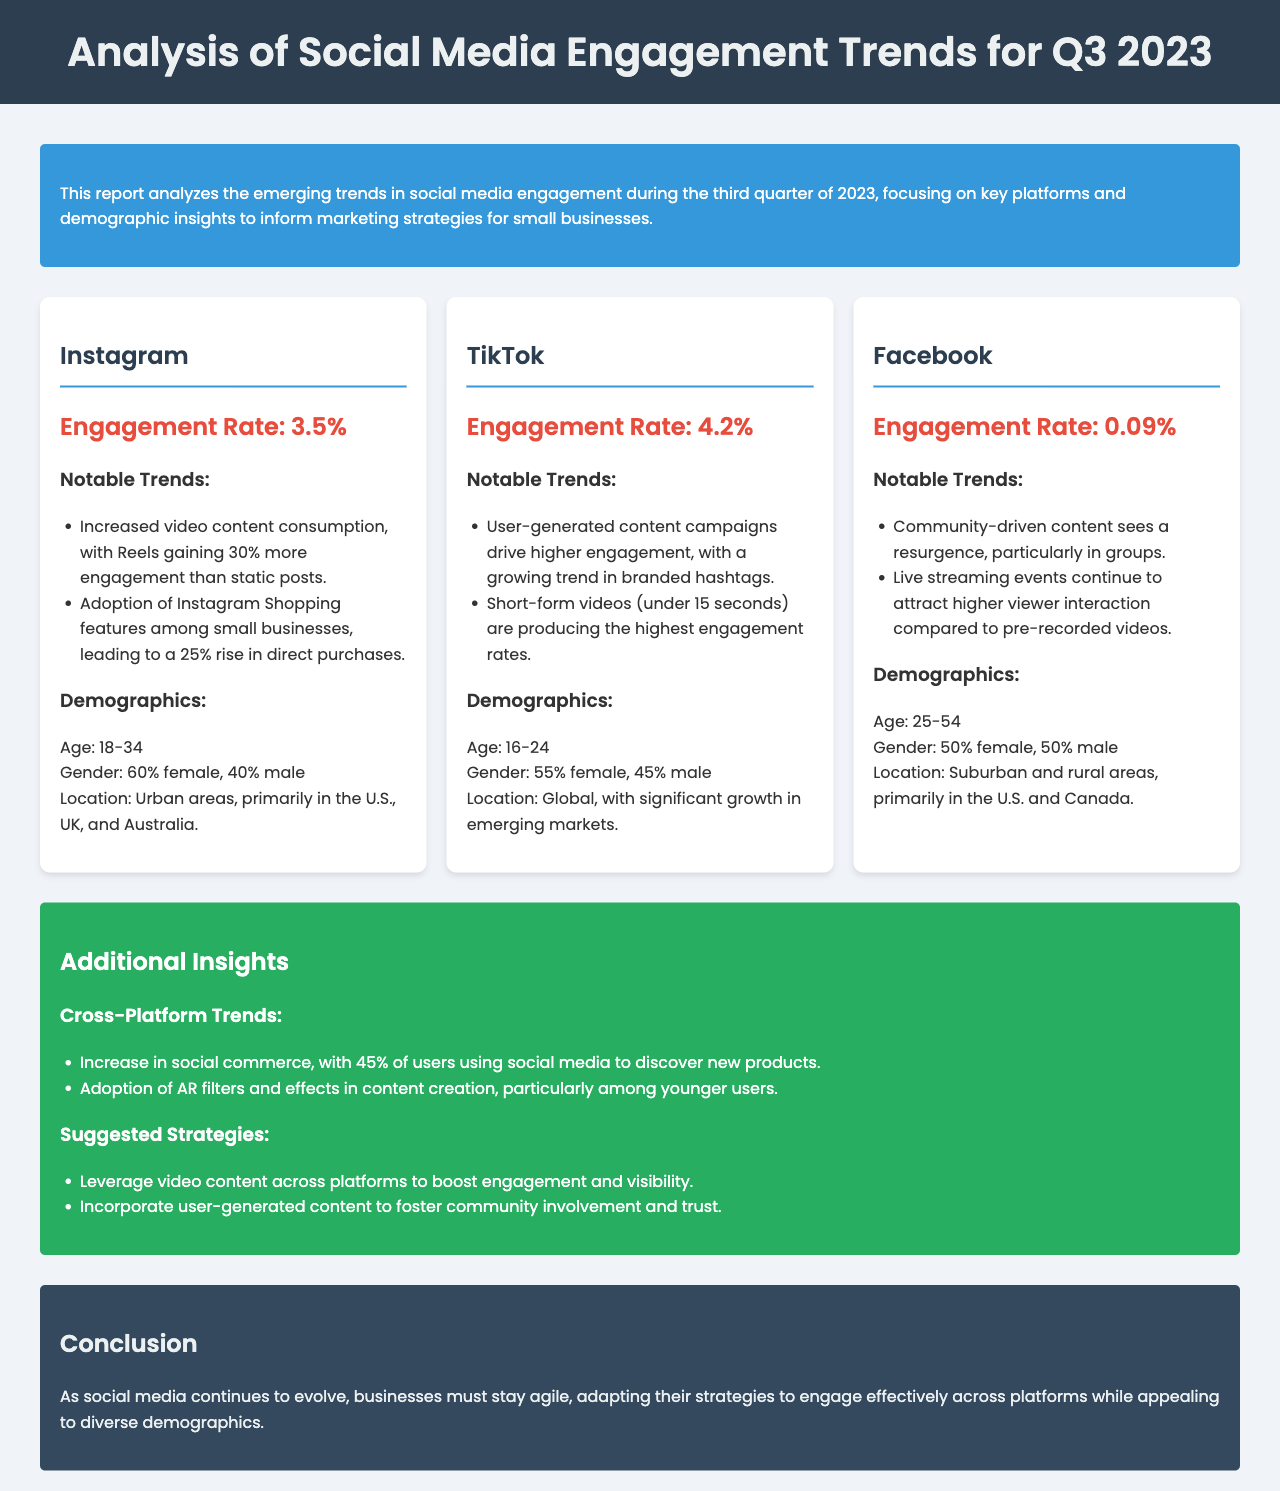What is the engagement rate for Instagram? The engagement rate for Instagram is highlighted as 3.5%.
Answer: 3.5% What notable trend is associated with TikTok? One notable trend is that user-generated content campaigns drive higher engagement, with a growing trend in branded hashtags.
Answer: User-generated content campaigns What percentage of users use social media to discover new products? The document states that 45% of users use social media to discover new products.
Answer: 45% What is the primary age demographic for Facebook users? The primary age demographic for Facebook users is stated as 25-54.
Answer: 25-54 Which platform has the highest engagement rate? The platform with the highest engagement rate mentioned is TikTok at 4.2%.
Answer: TikTok What is a suggested strategy for boosting engagement? One suggested strategy is to leverage video content across platforms.
Answer: Leverage video content In which locations do the majority of Instagram users reside? Instagram users are primarily located in urban areas, specifically in the U.S., UK, and Australia.
Answer: Urban areas What type of content continues to attract higher viewer interaction on Facebook? Live streaming events continue to attract higher viewer interaction compared to pre-recorded videos.
Answer: Live streaming events What format is the document presented in? The document is presented in a report format focusing on social media engagement trends.
Answer: Report format 